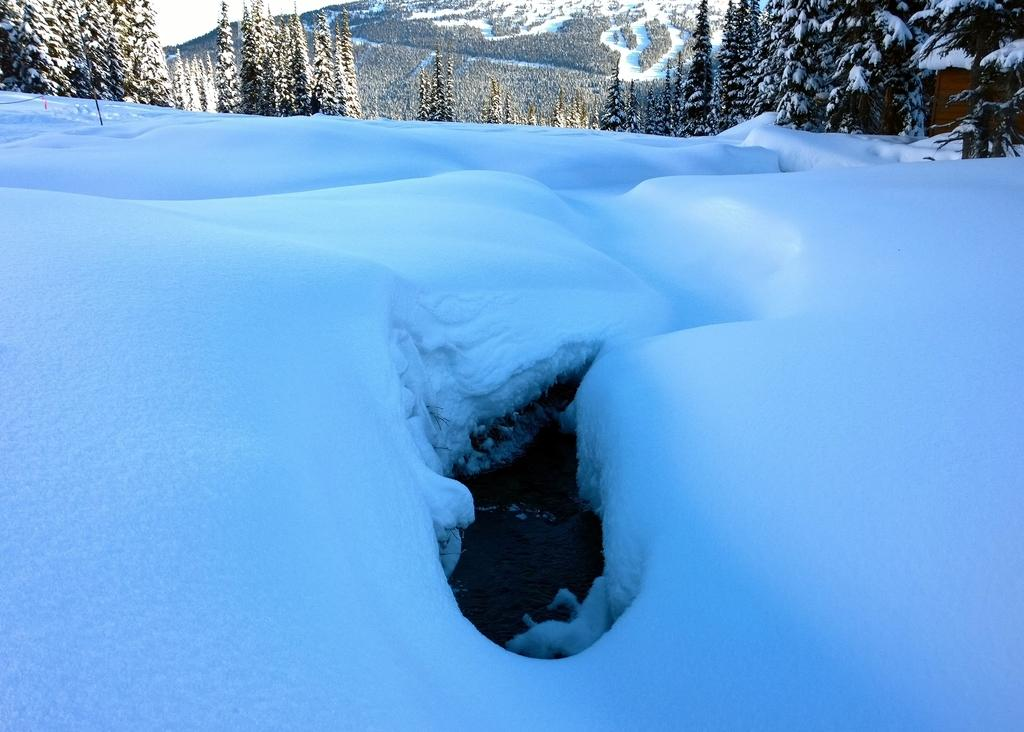What is the predominant weather condition in the image? There is snow in the image, indicating a cold and wintry condition. What can be seen in the background of the image? There are trees and a mountain in the background of the image. What is visible in the top left corner of the image? The sky is visible in the top left corner of the image. What type of structure can be seen in the top right corner of the image? There is a hut in the top right corner of the image. What type of writing can be seen on the mountain in the image? There is no writing visible on the mountain in the image. 